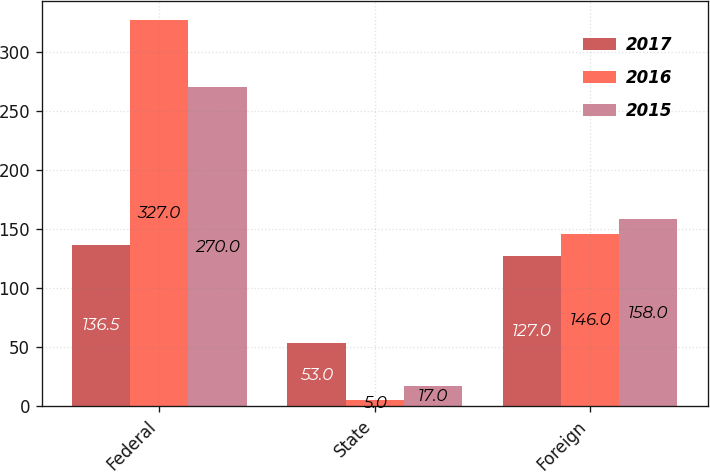Convert chart to OTSL. <chart><loc_0><loc_0><loc_500><loc_500><stacked_bar_chart><ecel><fcel>Federal<fcel>State<fcel>Foreign<nl><fcel>2017<fcel>136.5<fcel>53<fcel>127<nl><fcel>2016<fcel>327<fcel>5<fcel>146<nl><fcel>2015<fcel>270<fcel>17<fcel>158<nl></chart> 